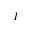<formula> <loc_0><loc_0><loc_500><loc_500>I</formula> 